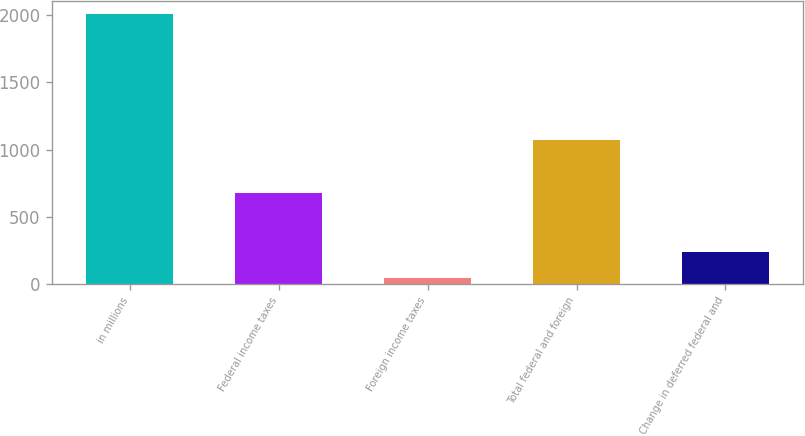Convert chart to OTSL. <chart><loc_0><loc_0><loc_500><loc_500><bar_chart><fcel>in millions<fcel>Federal income taxes<fcel>Foreign income taxes<fcel>Total federal and foreign<fcel>Change in deferred federal and<nl><fcel>2007<fcel>675<fcel>42<fcel>1068<fcel>238.5<nl></chart> 